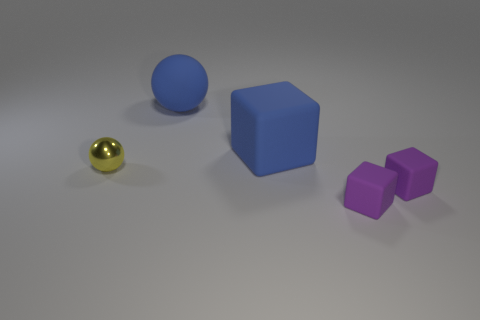How many other objects are there of the same color as the large rubber cube?
Give a very brief answer. 1. What is the size of the matte object that is the same color as the large block?
Provide a short and direct response. Large. Is the material of the big cube the same as the blue sphere?
Offer a terse response. Yes. How many objects are either things that are right of the yellow object or small things in front of the metal thing?
Your answer should be very brief. 4. Is there a purple cube that has the same size as the matte sphere?
Offer a very short reply. No. There is a large rubber object that is the same shape as the tiny shiny thing; what is its color?
Make the answer very short. Blue. Is there a big matte object behind the big object left of the blue cube?
Provide a succinct answer. No. Does the rubber object left of the large block have the same shape as the yellow metal thing?
Offer a terse response. Yes. The yellow object is what shape?
Give a very brief answer. Sphere. What number of other tiny spheres have the same material as the tiny ball?
Your answer should be compact. 0. 